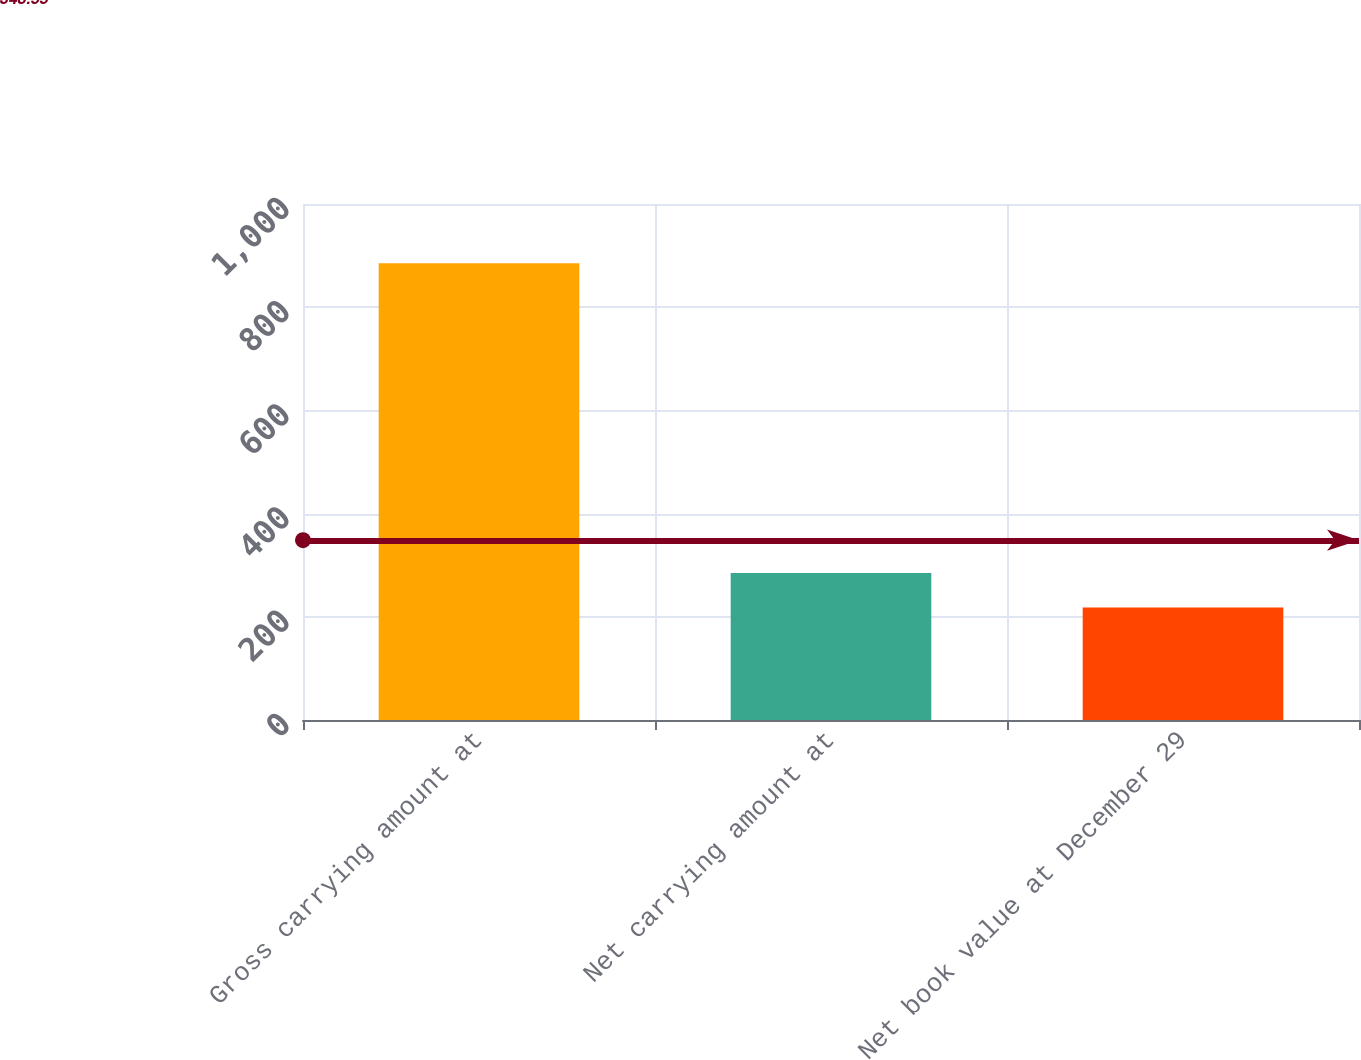Convert chart. <chart><loc_0><loc_0><loc_500><loc_500><bar_chart><fcel>Gross carrying amount at<fcel>Net carrying amount at<fcel>Net book value at December 29<nl><fcel>885<fcel>284.7<fcel>218<nl></chart> 